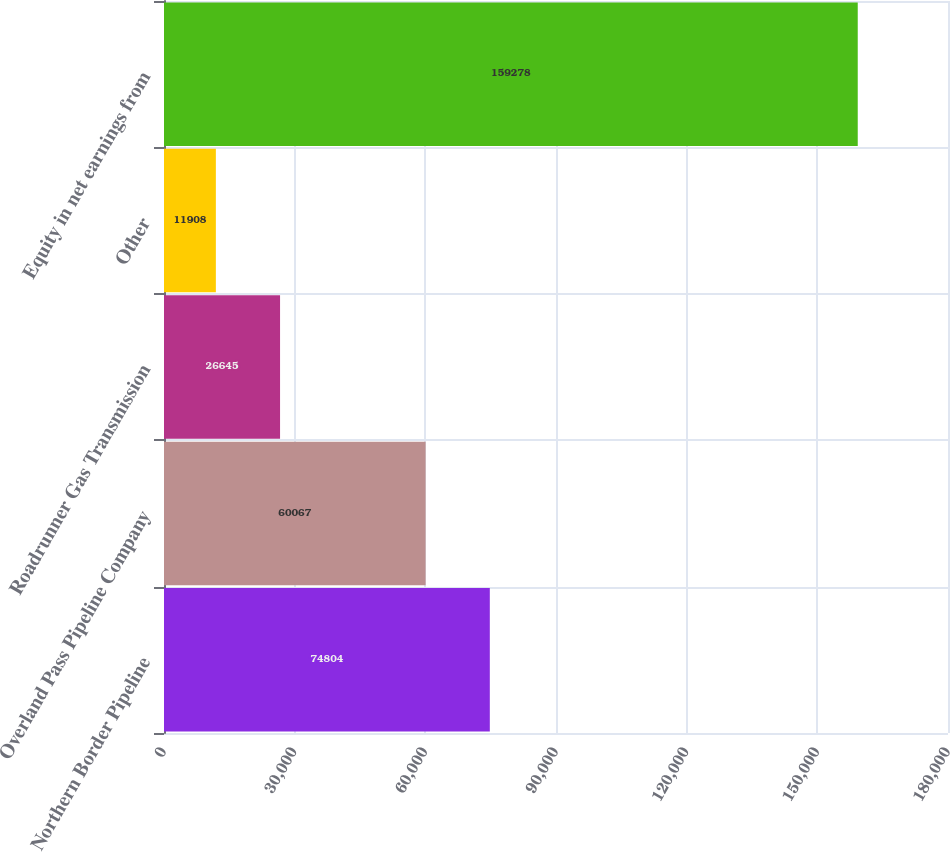Convert chart to OTSL. <chart><loc_0><loc_0><loc_500><loc_500><bar_chart><fcel>Northern Border Pipeline<fcel>Overland Pass Pipeline Company<fcel>Roadrunner Gas Transmission<fcel>Other<fcel>Equity in net earnings from<nl><fcel>74804<fcel>60067<fcel>26645<fcel>11908<fcel>159278<nl></chart> 